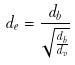<formula> <loc_0><loc_0><loc_500><loc_500>d _ { e } = \frac { d _ { b } } { \sqrt { \frac { d _ { b } } { d _ { v } } } }</formula> 